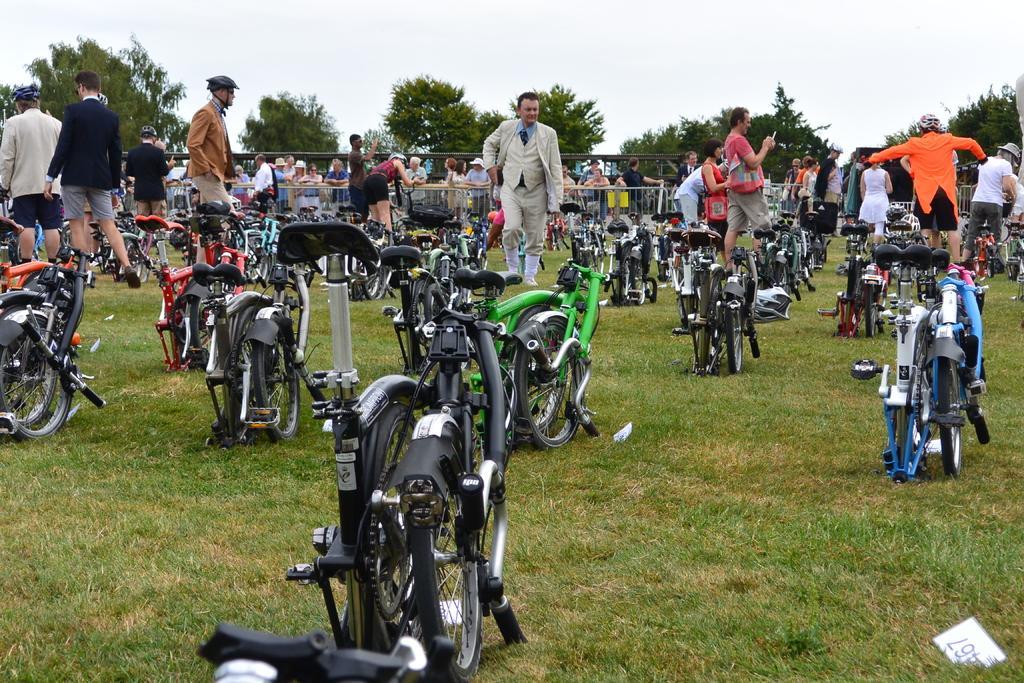How would you summarize this image in a sentence or two? This picture is clicked outside. In the center we can see the group of bicycles and we can see the group of persons, green grass, metal rods and some other objects. In the background we can see the sky and trees and group of persons. 